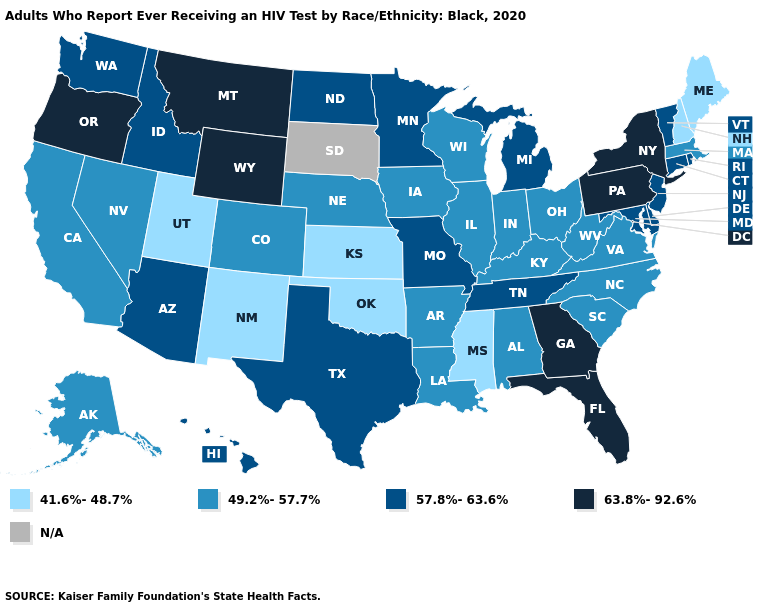What is the value of Pennsylvania?
Short answer required. 63.8%-92.6%. Among the states that border South Dakota , does Minnesota have the lowest value?
Keep it brief. No. Does California have the lowest value in the USA?
Keep it brief. No. Among the states that border Missouri , which have the highest value?
Be succinct. Tennessee. Does the first symbol in the legend represent the smallest category?
Quick response, please. Yes. What is the value of Pennsylvania?
Keep it brief. 63.8%-92.6%. What is the lowest value in the USA?
Be succinct. 41.6%-48.7%. What is the lowest value in the USA?
Quick response, please. 41.6%-48.7%. Name the states that have a value in the range 57.8%-63.6%?
Write a very short answer. Arizona, Connecticut, Delaware, Hawaii, Idaho, Maryland, Michigan, Minnesota, Missouri, New Jersey, North Dakota, Rhode Island, Tennessee, Texas, Vermont, Washington. Among the states that border Wisconsin , does Iowa have the lowest value?
Answer briefly. Yes. Among the states that border New Hampshire , does Vermont have the highest value?
Give a very brief answer. Yes. Name the states that have a value in the range 49.2%-57.7%?
Be succinct. Alabama, Alaska, Arkansas, California, Colorado, Illinois, Indiana, Iowa, Kentucky, Louisiana, Massachusetts, Nebraska, Nevada, North Carolina, Ohio, South Carolina, Virginia, West Virginia, Wisconsin. 